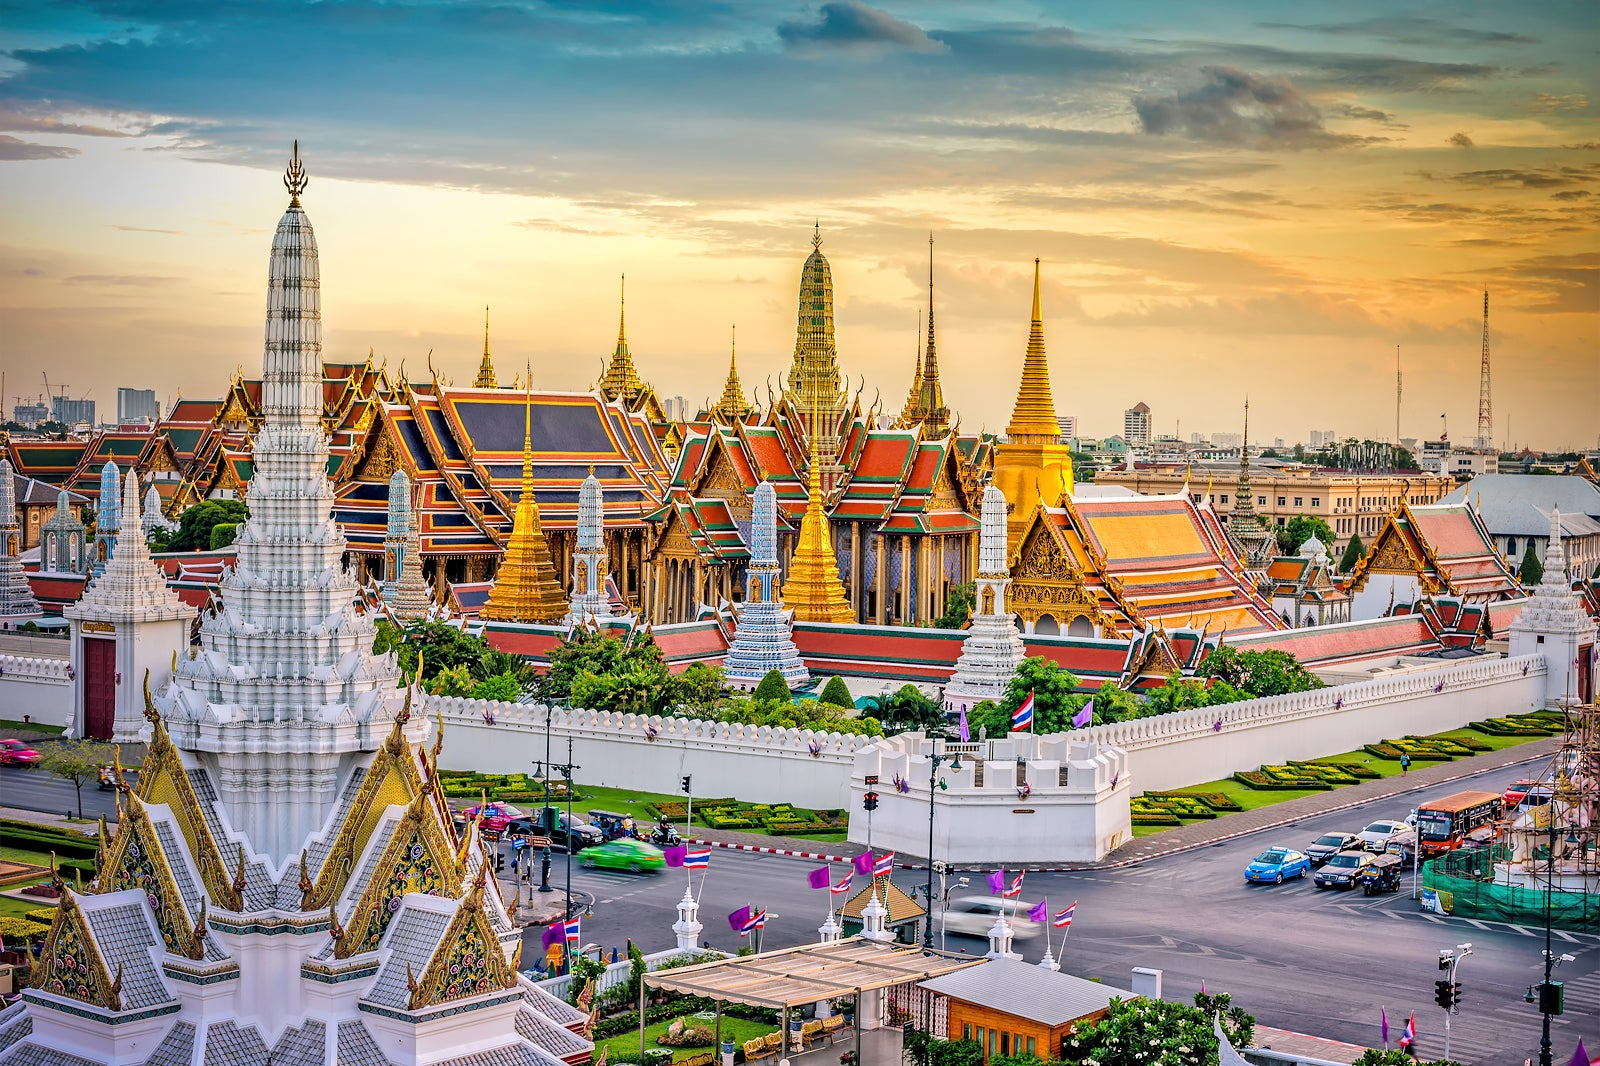Imagine being a guest at the Grand Palace during an ancient Thai royal ceremony. Describe your experience. As a guest at the Grand Palace during an ancient Thai royal ceremony, you would be immersed in an atmosphere of grandeur and ritualistic splendor. Entering through the grand gates, you would first be greeted by the solemnity of the Royal Guards, their traditional attire resplendent and their demeanor dignified. The air would be filled with the soft sounds of traditional Thai instruments, creating a serene yet majestic ambience. Walking through the elaborately decorated halls adorned with rich tapestries and precious artifacts, you’d witness courtiers and attendants moving with an air of grace and precision. The ceremony itself, held in a lavishly adorned hall, would be a visual feast of vibrant costumes, intricate dances, and symbolic gestures. Each moment would resonate with cultural significance and the timeless beauty of Thai traditions, leaving you with a profound sense of awe and reverence. 